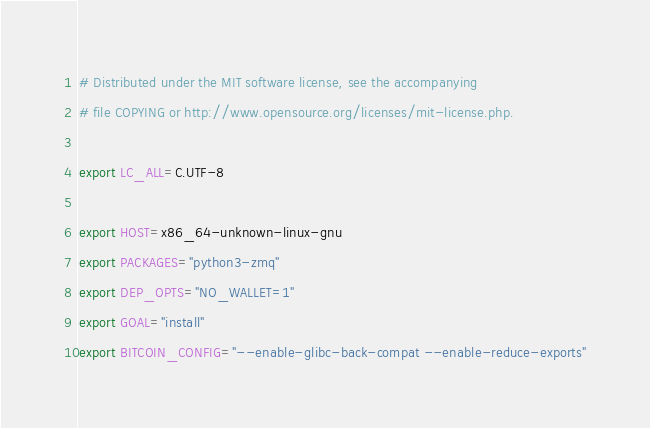Convert code to text. <code><loc_0><loc_0><loc_500><loc_500><_Bash_># Distributed under the MIT software license, see the accompanying
# file COPYING or http://www.opensource.org/licenses/mit-license.php.

export LC_ALL=C.UTF-8

export HOST=x86_64-unknown-linux-gnu
export PACKAGES="python3-zmq"
export DEP_OPTS="NO_WALLET=1"
export GOAL="install"
export BITCOIN_CONFIG="--enable-glibc-back-compat --enable-reduce-exports"
</code> 